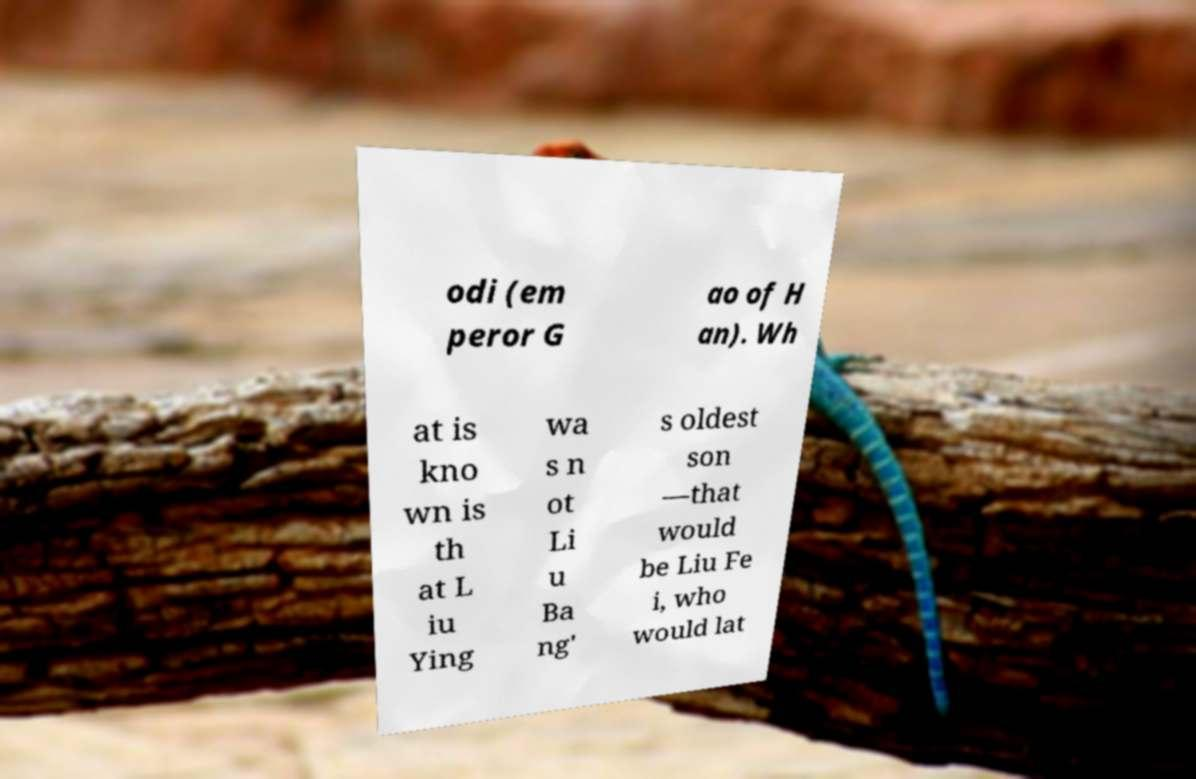Can you accurately transcribe the text from the provided image for me? odi (em peror G ao of H an). Wh at is kno wn is th at L iu Ying wa s n ot Li u Ba ng' s oldest son —that would be Liu Fe i, who would lat 